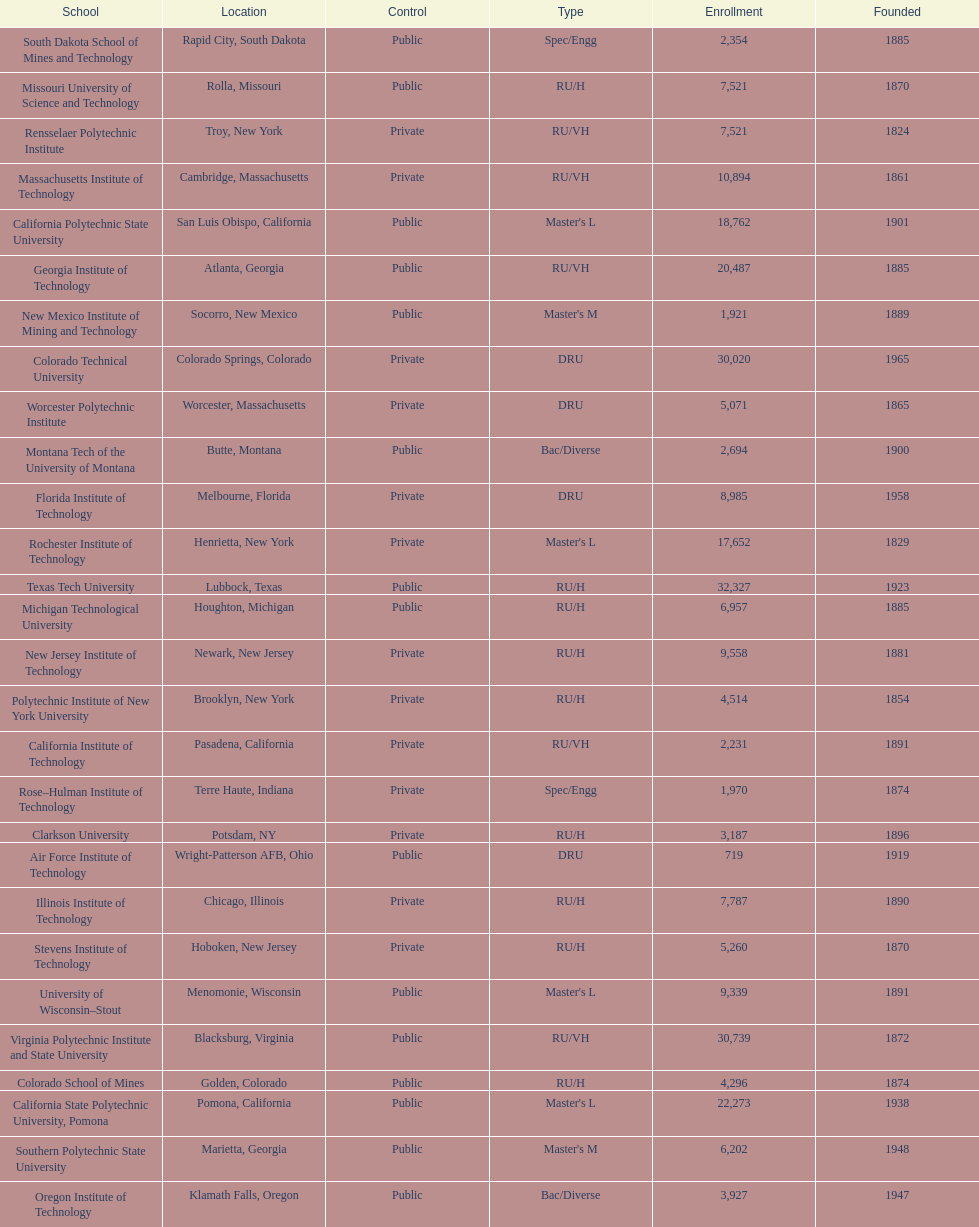What is the difference in enrollment between the top 2 schools listed in the table? 1512. 